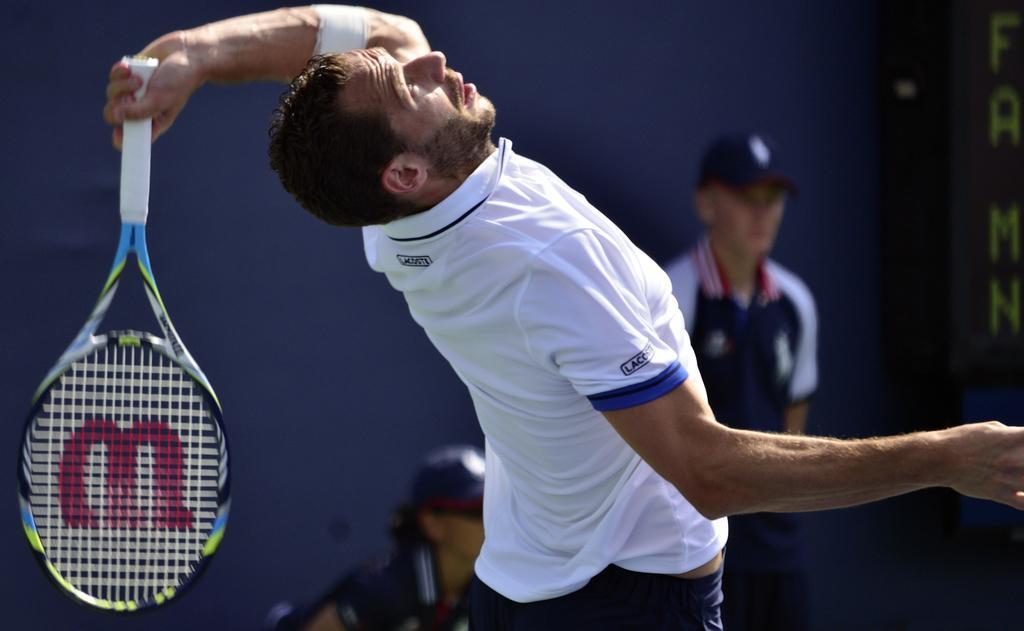Could you give a brief overview of what you see in this image? In this image we can see a person holding a tennis racket and behind him there are two people, on the right side of the image there is some text. 